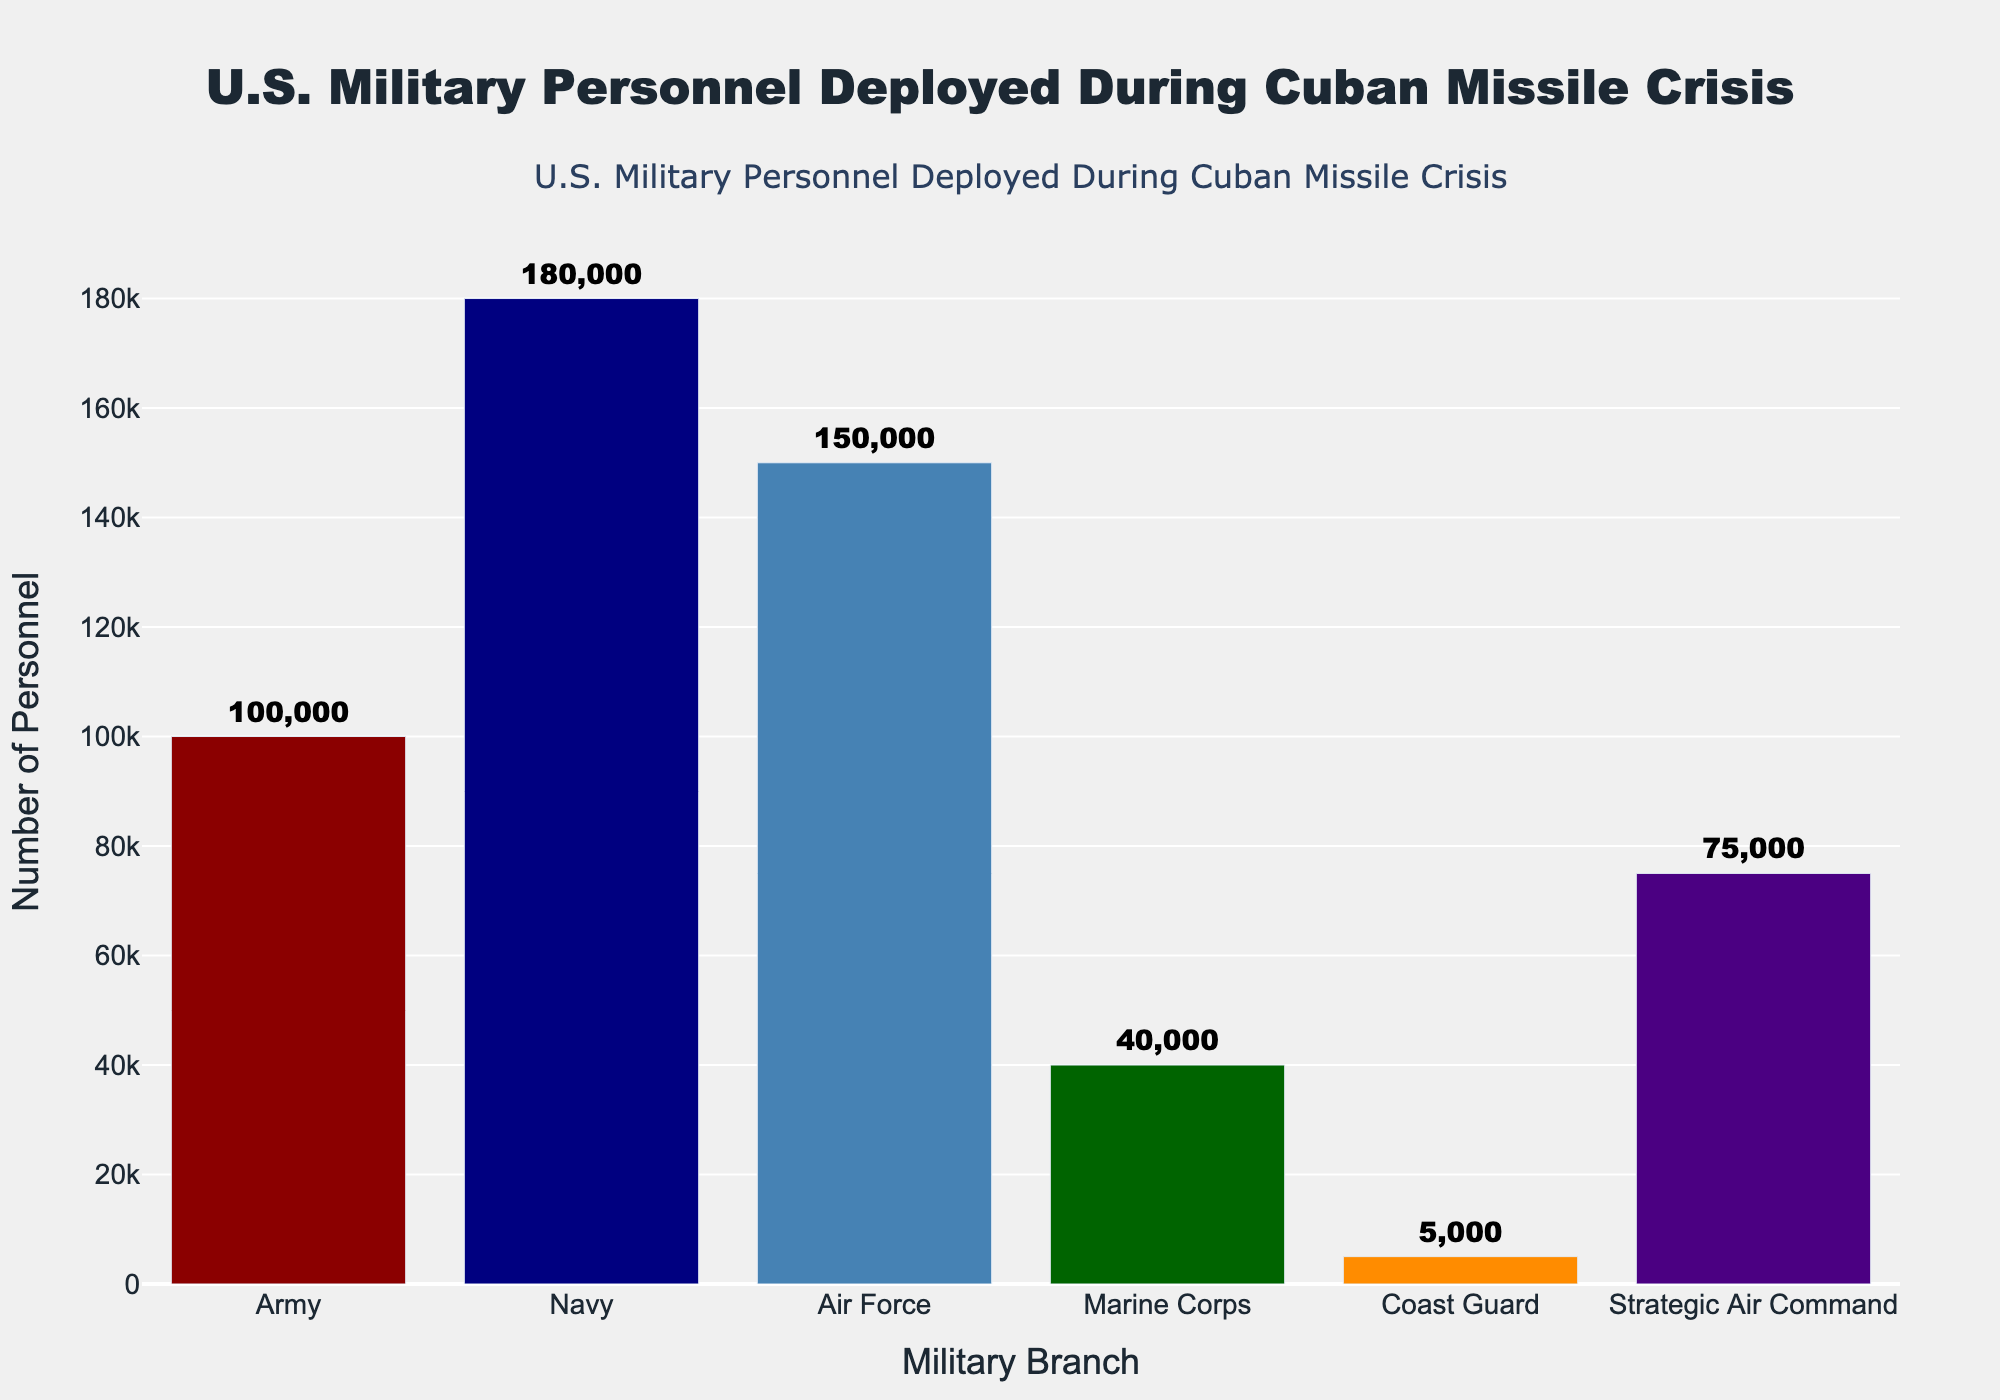what is the total number of personnel deployed? Sum the number of personnel deployed across all branches: 100,000 (Army) + 180,000 (Navy) + 150,000 (Air Force) + 40,000 (Marine Corps) + 5,000 (Coast Guard) + 75,000 (Strategic Air Command) = 550,000
Answer: 550,000 which military branch deployed the most personnel? Identify the bar with the highest value. The Navy deployed the most personnel with 180,000
Answer: Navy how many more personnel did the Air Force deploy compared to the Marine Corps? Subtract the Marine Corps number from the Air Force number: 150,000 (Air Force) - 40,000 (Marine Corps) = 110,000
Answer: 110,000 what is the average number of personnel deployed across all branches? Sum the number of personnel deployed and then divide by the number of branches: (100,000 + 180,000 + 150,000 + 40,000 + 5,000 + 75,000) / 6 = 91,667
Answer: 91,667 which branch deployed fewer personnel, the Coast Guard or Strategic Air Command? Compare the personnel numbers: Coast Guard (5,000) vs. Strategic Air Command (75,000). The Coast Guard deployed fewer personnel
Answer: Coast Guard what is the combined total of personnel deployed by the Army and Air Force? Add the number of personnel deployed by the Army and Air Force: 100,000 (Army) + 150,000 (Air Force) = 250,000
Answer: 250,000 if we group the branches into 'main' (Army, Navy, Air Force, Marine Corps) and 'other' branches (Coast Guard, Strategic Air Command), how many personnel were deployed by each group? Sum the personnel in each group: Main: (100,000 + 180,000 + 150,000 + 40,000) = 470,000, Other: (5,000 + 75,000) = 80,000
Answer: Main: 470,000, Other: 80,000 